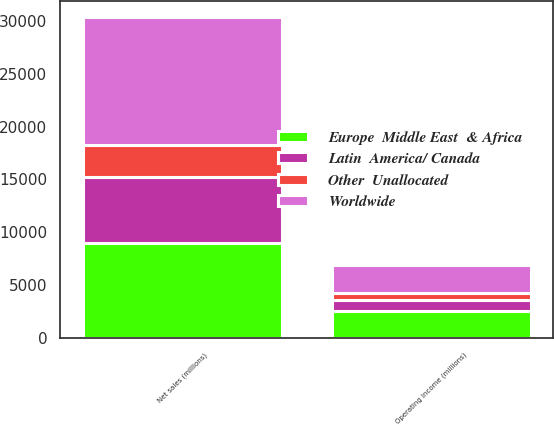Convert chart to OTSL. <chart><loc_0><loc_0><loc_500><loc_500><stacked_bar_chart><ecel><fcel>Net sales (millions)<fcel>Operating income (millions)<nl><fcel>Worldwide<fcel>12049<fcel>2647<nl><fcel>Europe  Middle East  & Africa<fcel>9041<fcel>2580<nl><fcel>Latin  America/ Canada<fcel>6228<fcel>1017<nl><fcel>Other  Unallocated<fcel>2982<fcel>706<nl></chart> 